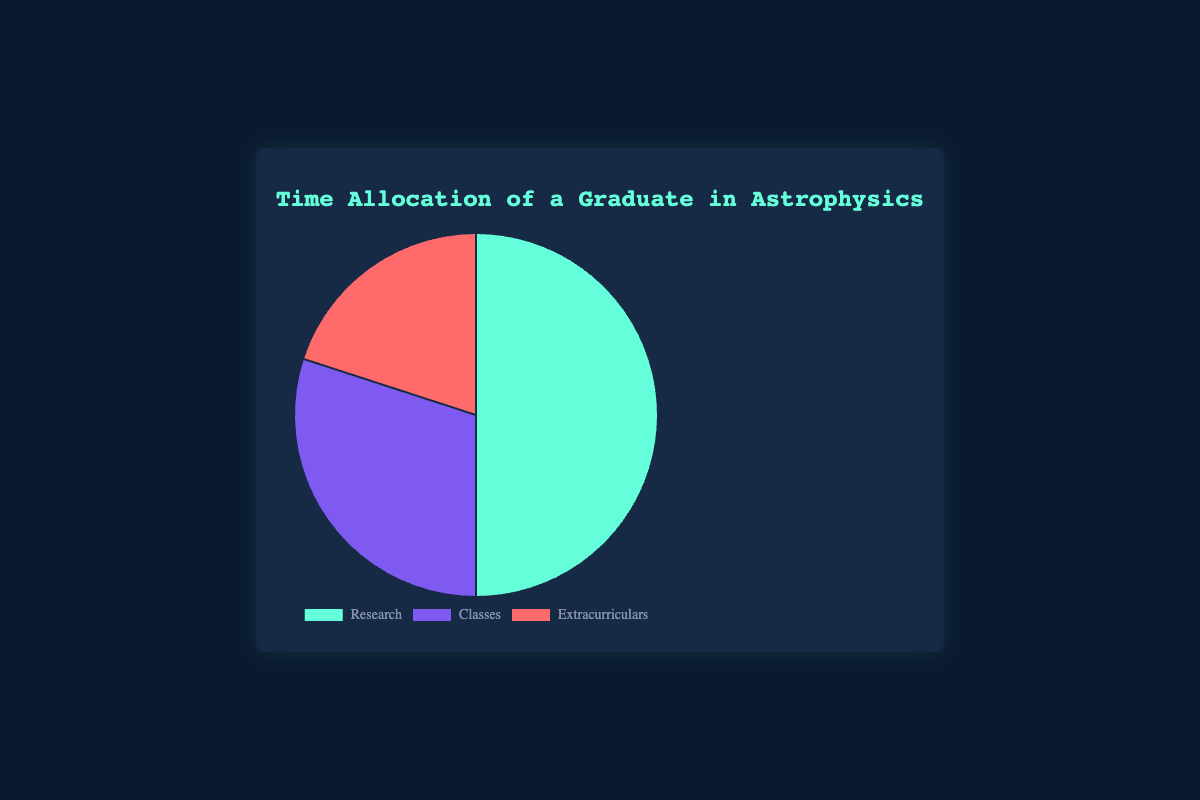What is the largest time allocation activity? The pie chart shows three activities: Research, Classes, and Extracurriculars. By looking at their respective percentages, Research has the largest allocation with 50%.
Answer: Research What is the total percentage of time allocated to Classes and Extracurriculars combined? Combine the percentages of Classes and Extracurriculars: 30% for Classes and 20% for Extracurriculars. Adding these gives 30 + 20 = 50%
Answer: 50% Which activity takes up the least amount of time? From the pie chart, the activity with the lowest percentage is Extracurriculars, which takes up 20% of the time.
Answer: Extracurriculars How much more time is allocated to Research than Classes? Subtract the percentage of Classes (30%) from the percentage of Research (50%): 50 - 30 = 20%
Answer: 20% Which activity has a time allocation that is half of the time allocated to Research? The time allocation for Research is 50%. The time allocation for Classes is 30%, and for Extracurriculars is 20%. Of these, 20% is half of 50% (since 50 / 2 = 25).
Answer: Extracurriculars How does the time allocated to Research compare to the sum of time allocated to Classes and Extracurriculars? Research has 50% of the time allocation. The sum of Classes (30%) and Extracurriculars (20%) is also 50%. Therefore, the time allocated to Research is equal to the sum of the other two activities.
Answer: Equal What is the ratio of time spent on Classes to Extracurriculars? The time allocation for Classes is 30%, and for Extracurriculars, it is 20%. The ratio of Classes to Extracurriculars is 30:20, which simplifies to 3:2.
Answer: 3:2 If the time allocated to Research were to decrease by 10%, which of the remaining activities would this 10% be equally distributed to? A decrease of 10% from Research (50% - 10% = 40%) would mean distributing this 10% equally between Classes and Extracurriculars. Each would then receive 5% (since 10% / 2 = 5%), making Classes 35% and Extracurriculars 25%.
Answer: Classes and Extracurriculars What color in the pie chart represents the activity with the most time allocation? The background color for the Research section can be identified by the visual attributes in the pie chart. The slice for Research, which has the highest percentage (50%), is visually shown in green.
Answer: Green If you combine the percentages of Research and Extracurriculars, what portion of the pie does this represent? Adding the allocation percentages of Research (50%) and Extracurriculars (20%) results in 50 + 20 = 70%. This combination represents 70% of the pie chart.
Answer: 70% 